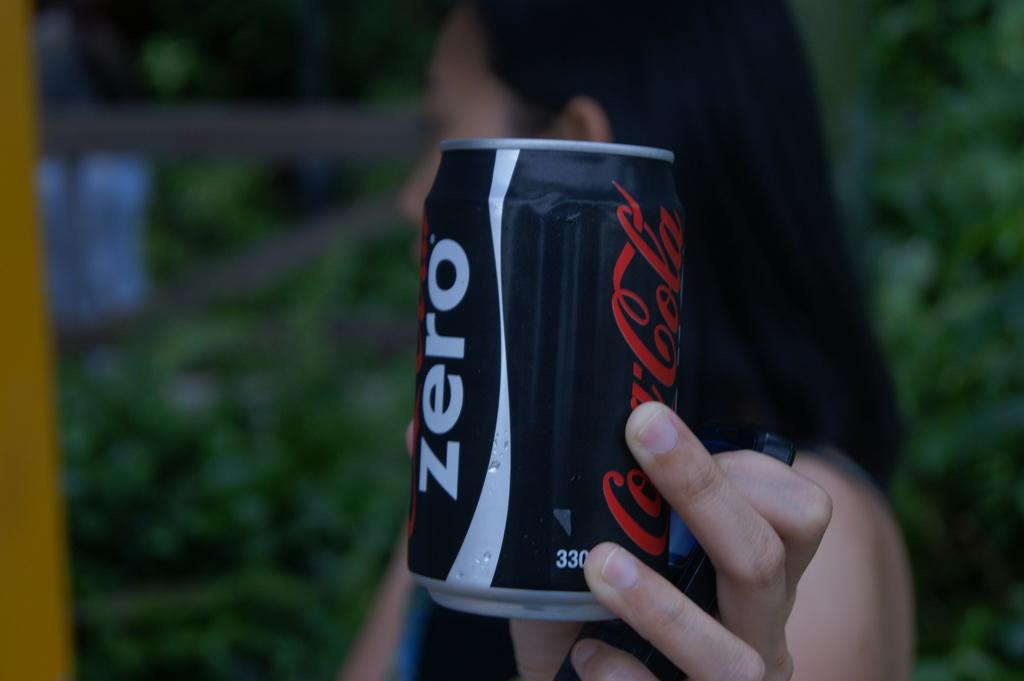Who is present in the image? There is a woman in the image. What is the woman holding in her hand? The woman is holding a black color coke tin. What can be seen on the coke tin? There is text on the coke tin. What else is the woman holding in her hand? The woman is also holding a mobile. How would you describe the background of the image? The background of the image is blurry. What type of fan is visible in the image? There is no fan present in the image. What kind of brush is being used by the woman in the image? There is no brush visible in the image. 